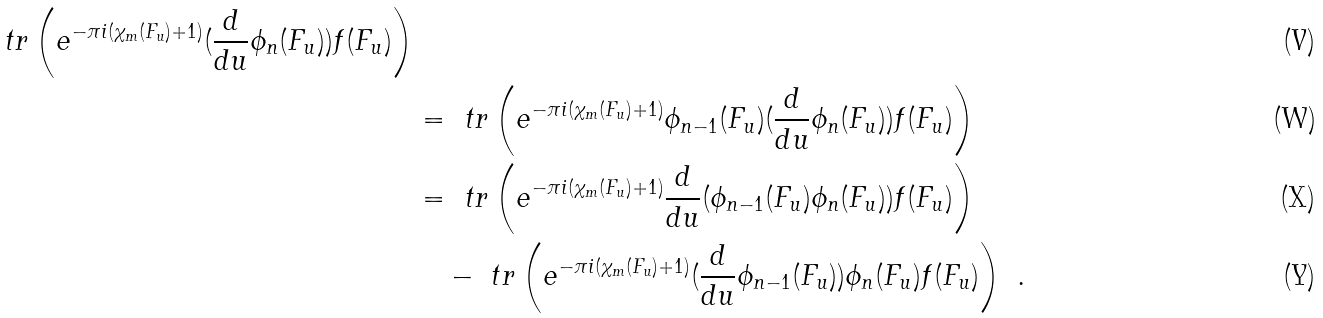Convert formula to latex. <formula><loc_0><loc_0><loc_500><loc_500>{ \ t r \left ( e ^ { - \pi i ( \chi _ { m } ( F _ { u } ) + 1 ) } ( \frac { d } { d u } \phi _ { n } ( F _ { u } ) ) f ( F _ { u } ) \right ) } \\ & = \ t r \left ( e ^ { - \pi i ( \chi _ { m } ( F _ { u } ) + 1 ) } \phi _ { n - 1 } ( F _ { u } ) ( \frac { d } { d u } \phi _ { n } ( F _ { u } ) ) f ( F _ { u } ) \right ) \\ & = \ t r \left ( e ^ { - \pi i ( \chi _ { m } ( F _ { u } ) + 1 ) } \frac { d } { d u } ( \phi _ { n - 1 } ( F _ { u } ) \phi _ { n } ( F _ { u } ) ) f ( F _ { u } ) \right ) \\ & \quad - \ t r \left ( e ^ { - \pi i ( \chi _ { m } ( F _ { u } ) + 1 ) } ( \frac { d } { d u } \phi _ { n - 1 } ( F _ { u } ) ) \phi _ { n } ( F _ { u } ) f ( F _ { u } ) \right ) \ .</formula> 